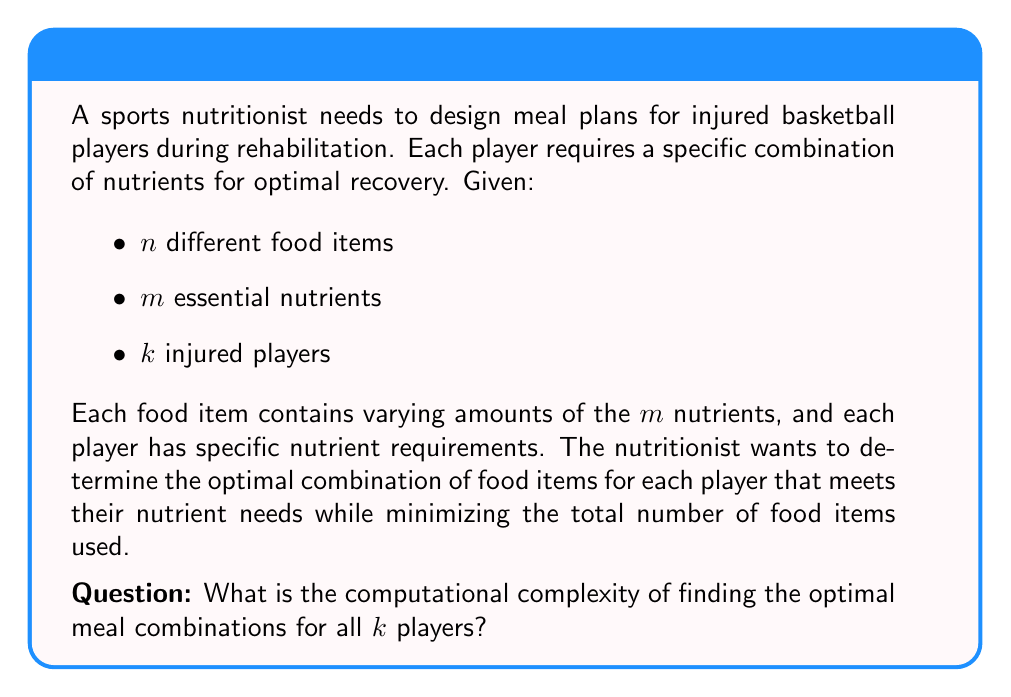Solve this math problem. To determine the computational complexity, we need to analyze the problem step-by-step:

1. This problem is a variant of the Knapsack problem, specifically the Multi-dimensional Knapsack Problem (MKP).

2. For each player, we need to solve an MKP instance:
   - $n$ food items correspond to the items in the knapsack
   - $m$ nutrients correspond to the dimensions of the knapsack
   - The goal is to maximize nutrient fulfillment while minimizing the number of food items

3. The MKP is known to be NP-hard, which means there's no known polynomial-time algorithm to solve it optimally.

4. For a single player, the time complexity is $O(2^n)$ using a naive approach (considering all possible combinations of food items).

5. We need to solve this for $k$ players, so the overall time complexity becomes $O(k \cdot 2^n)$.

6. This exponential time complexity indicates that the problem is computationally intractable for large values of $n$.

7. In terms of space complexity, we need to store information for $n$ food items, $m$ nutrients, and $k$ players, resulting in a space complexity of $O(nmk)$.

8. The decision version of this problem (Can we meet all nutrient requirements with at most $x$ food items?) is NP-complete.

Therefore, the problem of finding optimal meal combinations for all $k$ players is NP-hard, with a time complexity of $O(k \cdot 2^n)$ using a naive approach.
Answer: NP-hard, $O(k \cdot 2^n)$ time complexity 